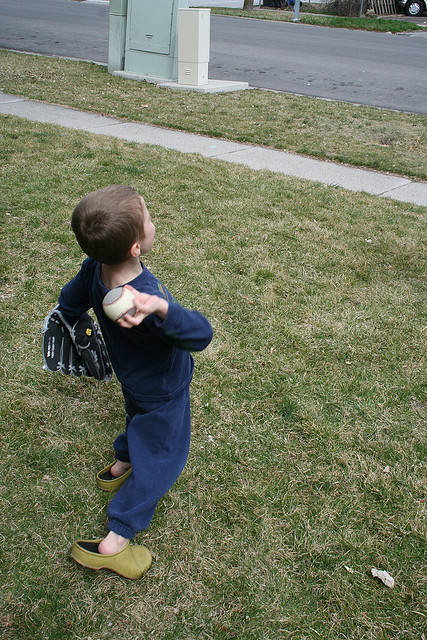<image>What is the boy looking at? I am not sure what the boy is looking at. It could be the street or sky. What is the boy looking at? The boy can be looking at the street, the sky, or a tree. I am not sure. 